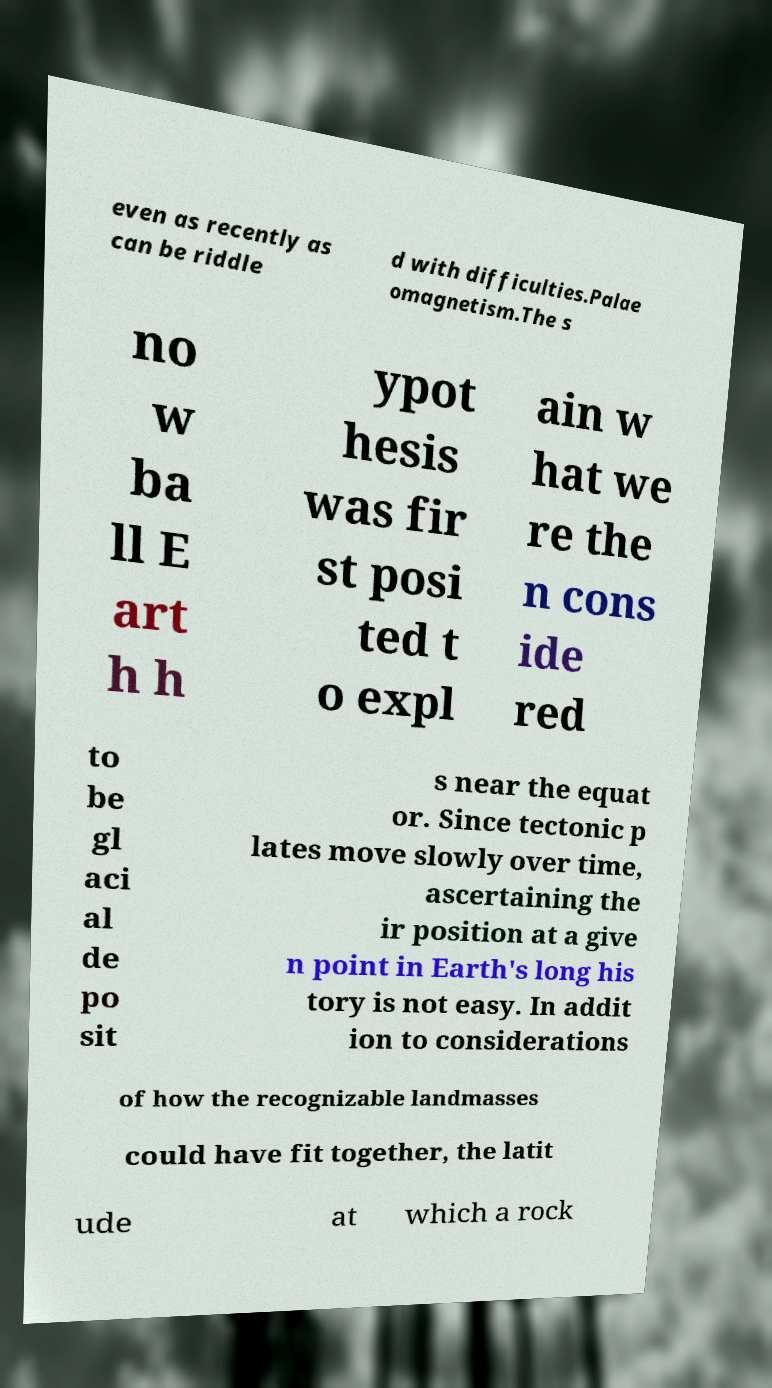Could you extract and type out the text from this image? even as recently as can be riddle d with difficulties.Palae omagnetism.The s no w ba ll E art h h ypot hesis was fir st posi ted t o expl ain w hat we re the n cons ide red to be gl aci al de po sit s near the equat or. Since tectonic p lates move slowly over time, ascertaining the ir position at a give n point in Earth's long his tory is not easy. In addit ion to considerations of how the recognizable landmasses could have fit together, the latit ude at which a rock 